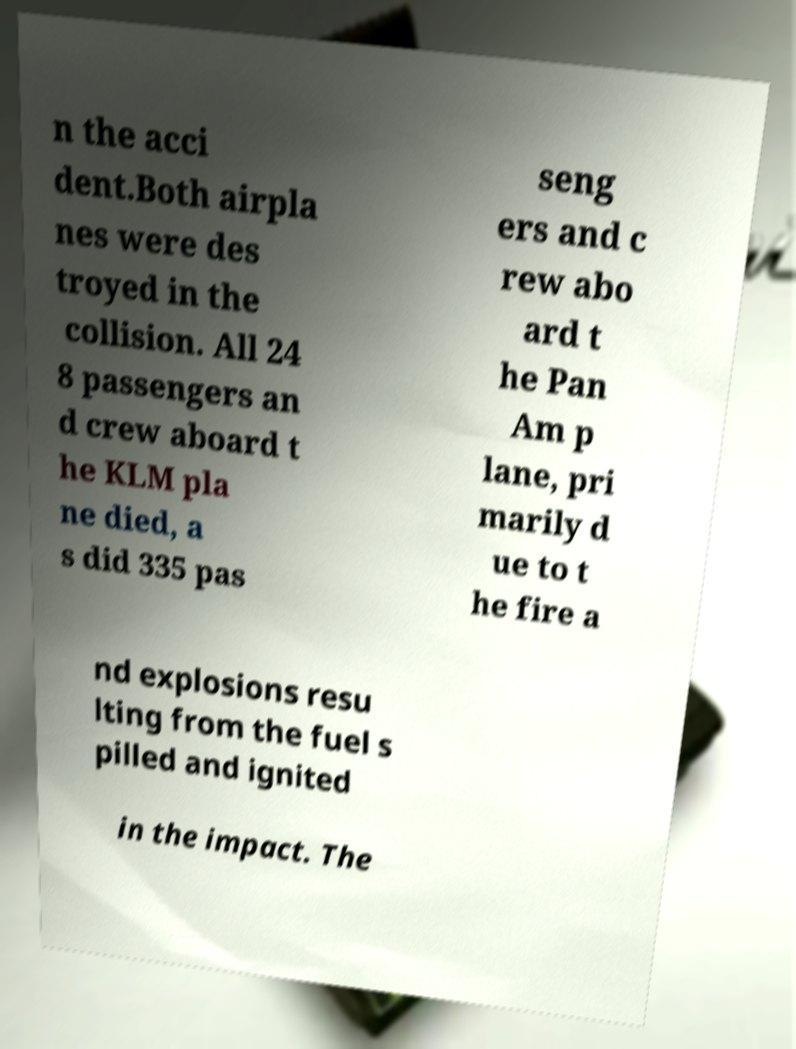Can you accurately transcribe the text from the provided image for me? n the acci dent.Both airpla nes were des troyed in the collision. All 24 8 passengers an d crew aboard t he KLM pla ne died, a s did 335 pas seng ers and c rew abo ard t he Pan Am p lane, pri marily d ue to t he fire a nd explosions resu lting from the fuel s pilled and ignited in the impact. The 